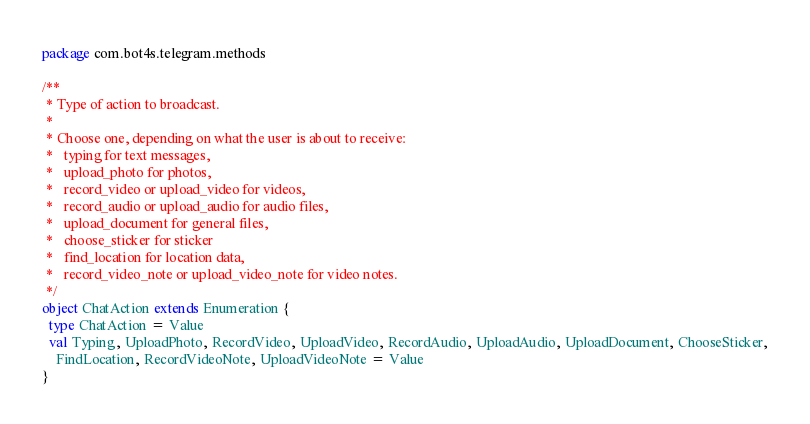Convert code to text. <code><loc_0><loc_0><loc_500><loc_500><_Scala_>package com.bot4s.telegram.methods

/**
 * Type of action to broadcast.
 *
 * Choose one, depending on what the user is about to receive:
 *   typing for text messages,
 *   upload_photo for photos,
 *   record_video or upload_video for videos,
 *   record_audio or upload_audio for audio files,
 *   upload_document for general files,
 *   choose_sticker for sticker
 *   find_location for location data,
 *   record_video_note or upload_video_note for video notes.
 */
object ChatAction extends Enumeration {
  type ChatAction = Value
  val Typing, UploadPhoto, RecordVideo, UploadVideo, RecordAudio, UploadAudio, UploadDocument, ChooseSticker,
    FindLocation, RecordVideoNote, UploadVideoNote = Value
}
</code> 